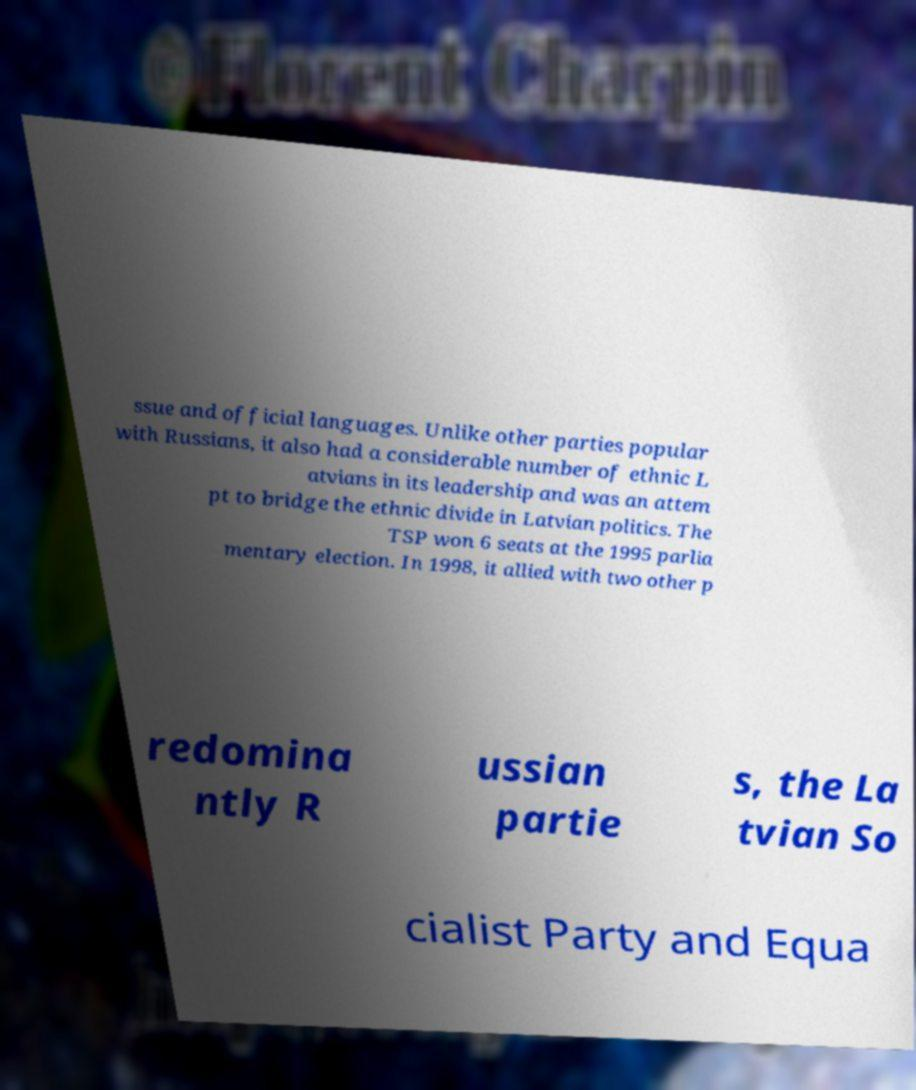Please identify and transcribe the text found in this image. ssue and official languages. Unlike other parties popular with Russians, it also had a considerable number of ethnic L atvians in its leadership and was an attem pt to bridge the ethnic divide in Latvian politics. The TSP won 6 seats at the 1995 parlia mentary election. In 1998, it allied with two other p redomina ntly R ussian partie s, the La tvian So cialist Party and Equa 